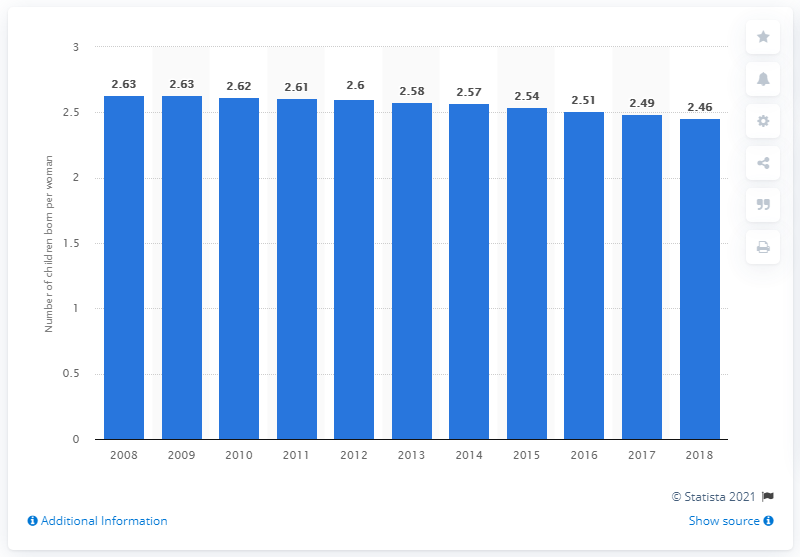Give some essential details in this illustration. In 2018, the fertility rate in Panama was 2.46. 